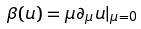Convert formula to latex. <formula><loc_0><loc_0><loc_500><loc_500>\beta ( u ) = \mu \partial _ { \mu } u | _ { \mu = 0 }</formula> 